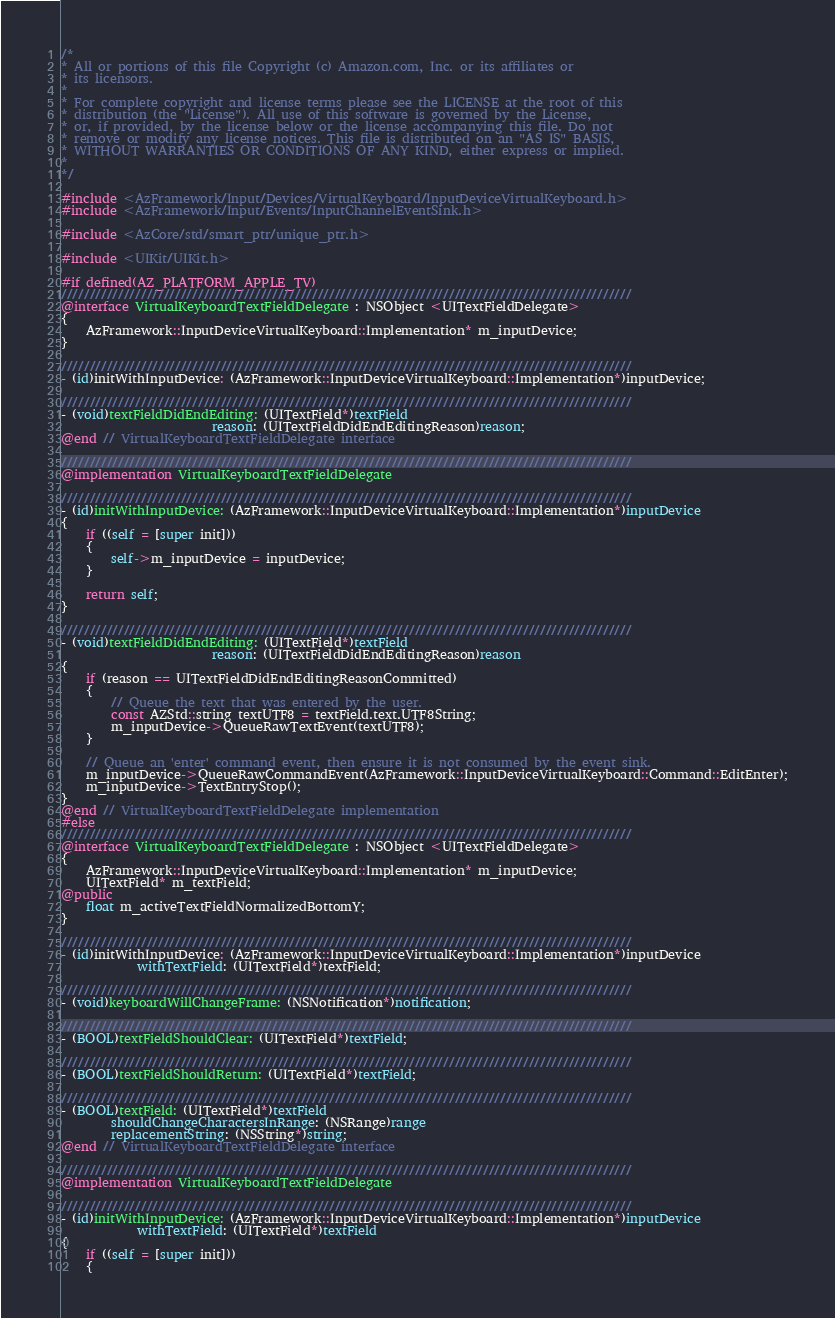Convert code to text. <code><loc_0><loc_0><loc_500><loc_500><_ObjectiveC_>/*
* All or portions of this file Copyright (c) Amazon.com, Inc. or its affiliates or
* its licensors.
*
* For complete copyright and license terms please see the LICENSE at the root of this
* distribution (the "License"). All use of this software is governed by the License,
* or, if provided, by the license below or the license accompanying this file. Do not
* remove or modify any license notices. This file is distributed on an "AS IS" BASIS,
* WITHOUT WARRANTIES OR CONDITIONS OF ANY KIND, either express or implied.
*
*/

#include <AzFramework/Input/Devices/VirtualKeyboard/InputDeviceVirtualKeyboard.h>
#include <AzFramework/Input/Events/InputChannelEventSink.h>

#include <AzCore/std/smart_ptr/unique_ptr.h>

#include <UIKit/UIKit.h>

#if defined(AZ_PLATFORM_APPLE_TV)
////////////////////////////////////////////////////////////////////////////////////////////////////
@interface VirtualKeyboardTextFieldDelegate : NSObject <UITextFieldDelegate>
{
    AzFramework::InputDeviceVirtualKeyboard::Implementation* m_inputDevice;
}

////////////////////////////////////////////////////////////////////////////////////////////////////
- (id)initWithInputDevice: (AzFramework::InputDeviceVirtualKeyboard::Implementation*)inputDevice;

////////////////////////////////////////////////////////////////////////////////////////////////////
- (void)textFieldDidEndEditing: (UITextField*)textField
                        reason: (UITextFieldDidEndEditingReason)reason;
@end // VirtualKeyboardTextFieldDelegate interface

////////////////////////////////////////////////////////////////////////////////////////////////////
@implementation VirtualKeyboardTextFieldDelegate

////////////////////////////////////////////////////////////////////////////////////////////////////
- (id)initWithInputDevice: (AzFramework::InputDeviceVirtualKeyboard::Implementation*)inputDevice
{
    if ((self = [super init]))
    {
        self->m_inputDevice = inputDevice;
    }

    return self;
}

////////////////////////////////////////////////////////////////////////////////////////////////////
- (void)textFieldDidEndEditing: (UITextField*)textField
                        reason: (UITextFieldDidEndEditingReason)reason
{
    if (reason == UITextFieldDidEndEditingReasonCommitted)
    {
        // Queue the text that was entered by the user.
        const AZStd::string textUTF8 = textField.text.UTF8String;
        m_inputDevice->QueueRawTextEvent(textUTF8);
    }

    // Queue an 'enter' command event, then ensure it is not consumed by the event sink.
    m_inputDevice->QueueRawCommandEvent(AzFramework::InputDeviceVirtualKeyboard::Command::EditEnter);
    m_inputDevice->TextEntryStop();
}
@end // VirtualKeyboardTextFieldDelegate implementation
#else
////////////////////////////////////////////////////////////////////////////////////////////////////
@interface VirtualKeyboardTextFieldDelegate : NSObject <UITextFieldDelegate>
{
    AzFramework::InputDeviceVirtualKeyboard::Implementation* m_inputDevice;
    UITextField* m_textField;
@public
    float m_activeTextFieldNormalizedBottomY;
}

////////////////////////////////////////////////////////////////////////////////////////////////////
- (id)initWithInputDevice: (AzFramework::InputDeviceVirtualKeyboard::Implementation*)inputDevice
            withTextField: (UITextField*)textField;

////////////////////////////////////////////////////////////////////////////////////////////////////
- (void)keyboardWillChangeFrame: (NSNotification*)notification;

////////////////////////////////////////////////////////////////////////////////////////////////////
- (BOOL)textFieldShouldClear: (UITextField*)textField;

////////////////////////////////////////////////////////////////////////////////////////////////////
- (BOOL)textFieldShouldReturn: (UITextField*)textField;

////////////////////////////////////////////////////////////////////////////////////////////////////
- (BOOL)textField: (UITextField*)textField
        shouldChangeCharactersInRange: (NSRange)range
        replacementString: (NSString*)string;
@end // VirtualKeyboardTextFieldDelegate interface

////////////////////////////////////////////////////////////////////////////////////////////////////
@implementation VirtualKeyboardTextFieldDelegate

////////////////////////////////////////////////////////////////////////////////////////////////////
- (id)initWithInputDevice: (AzFramework::InputDeviceVirtualKeyboard::Implementation*)inputDevice
            withTextField: (UITextField*)textField
{
    if ((self = [super init]))
    {</code> 